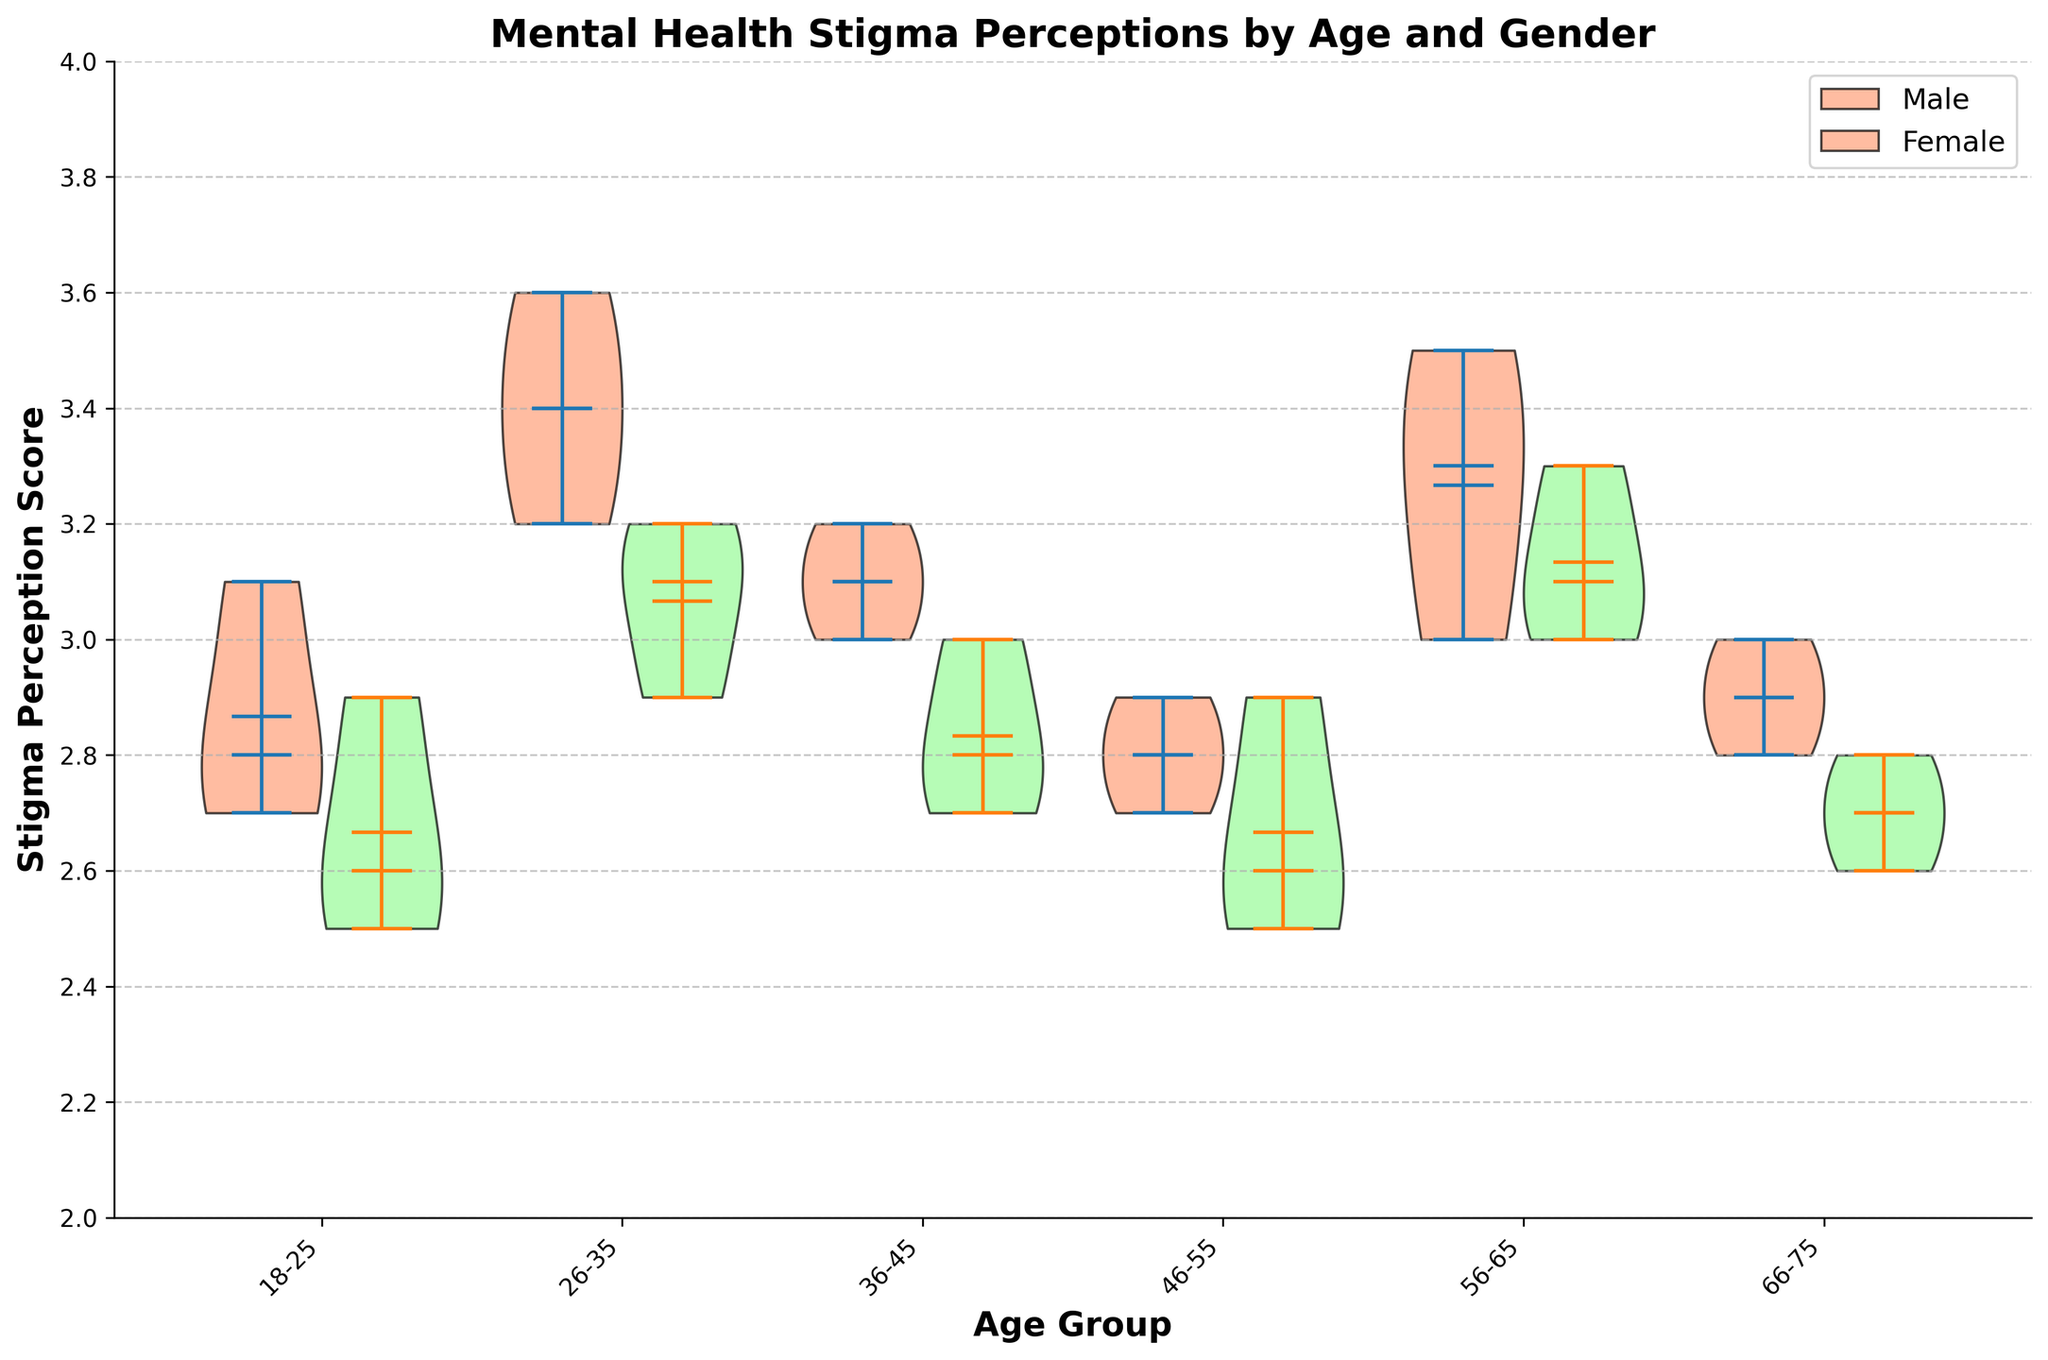What is the age group with the highest mean stigma perception for males? The highest position of the means for the male stigma perception can be observed in the age group 26-35.
Answer: 26-35 What is the age group with the lowest mean stigma perception for females? The lowest position of the means for the female stigma perception is found in the age group 18-25.
Answer: 18-25 Which gender has a higher stigma perception in the age group 46-55? By comparing the medians of both genders in the age group 46-55, we see that females have a slightly higher median stigma perception than males.
Answer: Females What is the range of stigma perception scores for males in the age group 36-45? The range can be determined by finding the difference between the highest and lowest points of the distribution. For males in 36-45, the range is from about 2.8 to 3.2.
Answer: 0.4 Is there any age group where males and females have the same median stigma perception? By inspecting the medians shown on the figure, none of the age groups have exactly the same median stigma perception for both males and females.
Answer: No In which age group do females have a higher stigma perception than males? By comparing all the median values for each age group, it is evident that there is no age group where females consistently have higher stigma perception than males. Even in age group 46-55 where females have a higher median, the difference is minimal.
Answer: None How does the stigma perception of females in the age group 56-65 compare to that of males in the same group? Males in 56-65 have higher median scores compared to females.
Answer: Males have higher median Which age group shows the smallest difference in stigma perception between genders? The smallest difference can be observed in the age group 26-35 where both genders have similar mean values close to each other.
Answer: 26-35 What is the highest stigma perception score for females in any age group? By observing the upper extreme value of the distributions, the highest stigma perception score for females is about 3.3, found in the age group 56-65.
Answer: 3.3 Comparing age groups 18-25 and 66-75, which shows a wider spread of stigma perception scores for males? The spread is wider for males in the age group 18-25 compared to 66-75, as seen by the longer violin shape.
Answer: 18-25 